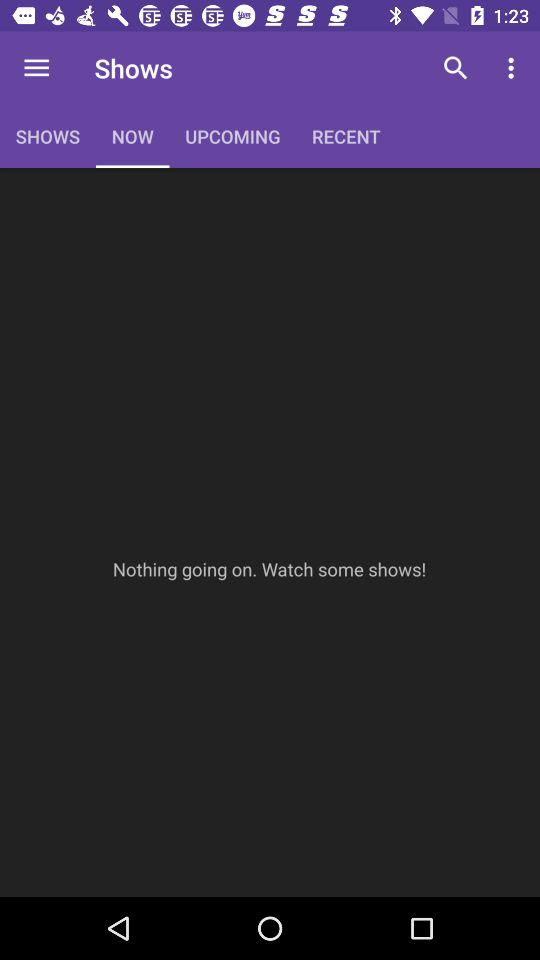What is the selected option in the shows? The selected option is "NOW". 